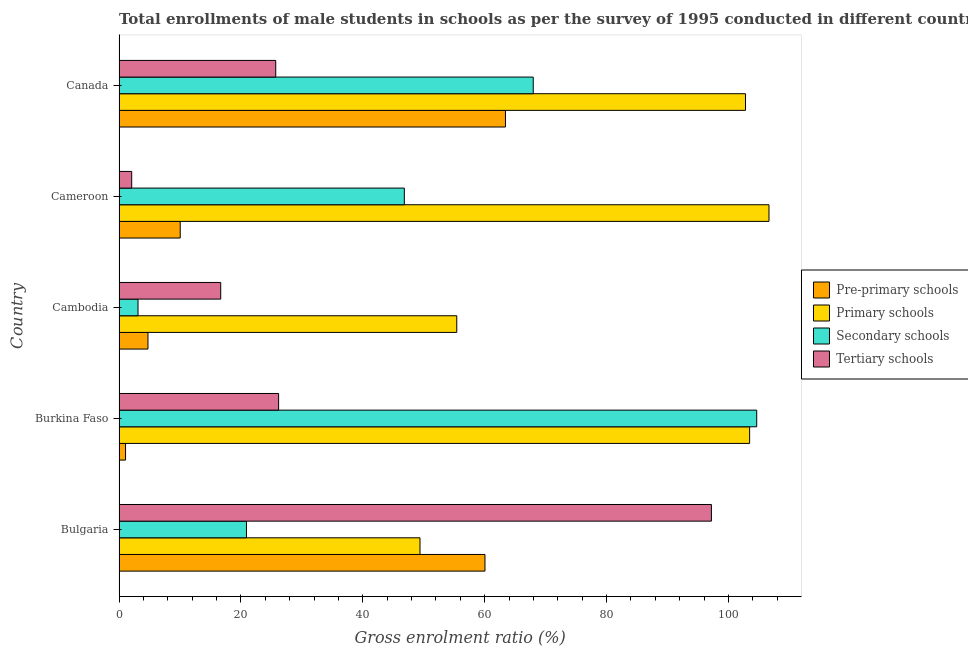How many bars are there on the 1st tick from the bottom?
Your answer should be compact. 4. What is the label of the 2nd group of bars from the top?
Keep it short and to the point. Cameroon. In how many cases, is the number of bars for a given country not equal to the number of legend labels?
Give a very brief answer. 0. What is the gross enrolment ratio(male) in secondary schools in Bulgaria?
Your answer should be very brief. 20.91. Across all countries, what is the maximum gross enrolment ratio(male) in primary schools?
Keep it short and to the point. 106.66. Across all countries, what is the minimum gross enrolment ratio(male) in secondary schools?
Provide a succinct answer. 3.11. In which country was the gross enrolment ratio(male) in tertiary schools maximum?
Provide a short and direct response. Bulgaria. What is the total gross enrolment ratio(male) in secondary schools in the graph?
Offer a terse response. 243.45. What is the difference between the gross enrolment ratio(male) in pre-primary schools in Burkina Faso and that in Cameroon?
Offer a terse response. -8.97. What is the difference between the gross enrolment ratio(male) in primary schools in Canada and the gross enrolment ratio(male) in pre-primary schools in Burkina Faso?
Offer a very short reply. 101.74. What is the average gross enrolment ratio(male) in primary schools per country?
Keep it short and to the point. 83.55. What is the difference between the gross enrolment ratio(male) in secondary schools and gross enrolment ratio(male) in primary schools in Canada?
Keep it short and to the point. -34.83. Is the gross enrolment ratio(male) in pre-primary schools in Cambodia less than that in Cameroon?
Give a very brief answer. Yes. What is the difference between the highest and the second highest gross enrolment ratio(male) in primary schools?
Your response must be concise. 3.18. What is the difference between the highest and the lowest gross enrolment ratio(male) in primary schools?
Provide a short and direct response. 57.27. What does the 3rd bar from the top in Burkina Faso represents?
Provide a succinct answer. Primary schools. What does the 1st bar from the bottom in Cameroon represents?
Keep it short and to the point. Pre-primary schools. Is it the case that in every country, the sum of the gross enrolment ratio(male) in pre-primary schools and gross enrolment ratio(male) in primary schools is greater than the gross enrolment ratio(male) in secondary schools?
Your answer should be compact. No. Are all the bars in the graph horizontal?
Give a very brief answer. Yes. How many countries are there in the graph?
Give a very brief answer. 5. What is the difference between two consecutive major ticks on the X-axis?
Provide a succinct answer. 20. Does the graph contain any zero values?
Ensure brevity in your answer.  No. Does the graph contain grids?
Keep it short and to the point. No. How many legend labels are there?
Provide a succinct answer. 4. What is the title of the graph?
Offer a very short reply. Total enrollments of male students in schools as per the survey of 1995 conducted in different countries. Does "Fish species" appear as one of the legend labels in the graph?
Offer a very short reply. No. What is the label or title of the Y-axis?
Make the answer very short. Country. What is the Gross enrolment ratio (%) of Pre-primary schools in Bulgaria?
Offer a very short reply. 60.05. What is the Gross enrolment ratio (%) in Primary schools in Bulgaria?
Provide a short and direct response. 49.39. What is the Gross enrolment ratio (%) of Secondary schools in Bulgaria?
Offer a terse response. 20.91. What is the Gross enrolment ratio (%) in Tertiary schools in Bulgaria?
Your response must be concise. 97.21. What is the Gross enrolment ratio (%) in Pre-primary schools in Burkina Faso?
Provide a succinct answer. 1.06. What is the Gross enrolment ratio (%) of Primary schools in Burkina Faso?
Offer a very short reply. 103.48. What is the Gross enrolment ratio (%) in Secondary schools in Burkina Faso?
Provide a succinct answer. 104.64. What is the Gross enrolment ratio (%) of Tertiary schools in Burkina Faso?
Your answer should be very brief. 26.18. What is the Gross enrolment ratio (%) of Pre-primary schools in Cambodia?
Offer a terse response. 4.75. What is the Gross enrolment ratio (%) in Primary schools in Cambodia?
Your answer should be compact. 55.42. What is the Gross enrolment ratio (%) in Secondary schools in Cambodia?
Your answer should be compact. 3.11. What is the Gross enrolment ratio (%) of Tertiary schools in Cambodia?
Provide a short and direct response. 16.68. What is the Gross enrolment ratio (%) of Pre-primary schools in Cameroon?
Your response must be concise. 10.04. What is the Gross enrolment ratio (%) of Primary schools in Cameroon?
Offer a very short reply. 106.66. What is the Gross enrolment ratio (%) of Secondary schools in Cameroon?
Offer a very short reply. 46.82. What is the Gross enrolment ratio (%) in Tertiary schools in Cameroon?
Provide a short and direct response. 2.08. What is the Gross enrolment ratio (%) of Pre-primary schools in Canada?
Give a very brief answer. 63.41. What is the Gross enrolment ratio (%) in Primary schools in Canada?
Ensure brevity in your answer.  102.8. What is the Gross enrolment ratio (%) in Secondary schools in Canada?
Ensure brevity in your answer.  67.97. What is the Gross enrolment ratio (%) of Tertiary schools in Canada?
Offer a very short reply. 25.71. Across all countries, what is the maximum Gross enrolment ratio (%) of Pre-primary schools?
Provide a succinct answer. 63.41. Across all countries, what is the maximum Gross enrolment ratio (%) of Primary schools?
Offer a very short reply. 106.66. Across all countries, what is the maximum Gross enrolment ratio (%) in Secondary schools?
Keep it short and to the point. 104.64. Across all countries, what is the maximum Gross enrolment ratio (%) of Tertiary schools?
Offer a terse response. 97.21. Across all countries, what is the minimum Gross enrolment ratio (%) in Pre-primary schools?
Provide a succinct answer. 1.06. Across all countries, what is the minimum Gross enrolment ratio (%) in Primary schools?
Keep it short and to the point. 49.39. Across all countries, what is the minimum Gross enrolment ratio (%) of Secondary schools?
Offer a very short reply. 3.11. Across all countries, what is the minimum Gross enrolment ratio (%) in Tertiary schools?
Your answer should be compact. 2.08. What is the total Gross enrolment ratio (%) in Pre-primary schools in the graph?
Ensure brevity in your answer.  139.31. What is the total Gross enrolment ratio (%) of Primary schools in the graph?
Make the answer very short. 417.76. What is the total Gross enrolment ratio (%) in Secondary schools in the graph?
Offer a terse response. 243.45. What is the total Gross enrolment ratio (%) of Tertiary schools in the graph?
Ensure brevity in your answer.  167.87. What is the difference between the Gross enrolment ratio (%) of Pre-primary schools in Bulgaria and that in Burkina Faso?
Keep it short and to the point. 58.99. What is the difference between the Gross enrolment ratio (%) in Primary schools in Bulgaria and that in Burkina Faso?
Your answer should be very brief. -54.09. What is the difference between the Gross enrolment ratio (%) in Secondary schools in Bulgaria and that in Burkina Faso?
Provide a succinct answer. -83.73. What is the difference between the Gross enrolment ratio (%) in Tertiary schools in Bulgaria and that in Burkina Faso?
Your response must be concise. 71.03. What is the difference between the Gross enrolment ratio (%) in Pre-primary schools in Bulgaria and that in Cambodia?
Make the answer very short. 55.3. What is the difference between the Gross enrolment ratio (%) in Primary schools in Bulgaria and that in Cambodia?
Offer a very short reply. -6.03. What is the difference between the Gross enrolment ratio (%) of Secondary schools in Bulgaria and that in Cambodia?
Provide a short and direct response. 17.8. What is the difference between the Gross enrolment ratio (%) of Tertiary schools in Bulgaria and that in Cambodia?
Keep it short and to the point. 80.53. What is the difference between the Gross enrolment ratio (%) of Pre-primary schools in Bulgaria and that in Cameroon?
Provide a short and direct response. 50.01. What is the difference between the Gross enrolment ratio (%) in Primary schools in Bulgaria and that in Cameroon?
Provide a succinct answer. -57.27. What is the difference between the Gross enrolment ratio (%) of Secondary schools in Bulgaria and that in Cameroon?
Ensure brevity in your answer.  -25.91. What is the difference between the Gross enrolment ratio (%) of Tertiary schools in Bulgaria and that in Cameroon?
Your answer should be very brief. 95.13. What is the difference between the Gross enrolment ratio (%) of Pre-primary schools in Bulgaria and that in Canada?
Provide a succinct answer. -3.36. What is the difference between the Gross enrolment ratio (%) in Primary schools in Bulgaria and that in Canada?
Ensure brevity in your answer.  -53.42. What is the difference between the Gross enrolment ratio (%) in Secondary schools in Bulgaria and that in Canada?
Offer a terse response. -47.06. What is the difference between the Gross enrolment ratio (%) in Tertiary schools in Bulgaria and that in Canada?
Ensure brevity in your answer.  71.5. What is the difference between the Gross enrolment ratio (%) of Pre-primary schools in Burkina Faso and that in Cambodia?
Your response must be concise. -3.68. What is the difference between the Gross enrolment ratio (%) of Primary schools in Burkina Faso and that in Cambodia?
Your response must be concise. 48.06. What is the difference between the Gross enrolment ratio (%) in Secondary schools in Burkina Faso and that in Cambodia?
Your response must be concise. 101.53. What is the difference between the Gross enrolment ratio (%) of Tertiary schools in Burkina Faso and that in Cambodia?
Your response must be concise. 9.5. What is the difference between the Gross enrolment ratio (%) of Pre-primary schools in Burkina Faso and that in Cameroon?
Make the answer very short. -8.97. What is the difference between the Gross enrolment ratio (%) of Primary schools in Burkina Faso and that in Cameroon?
Ensure brevity in your answer.  -3.18. What is the difference between the Gross enrolment ratio (%) in Secondary schools in Burkina Faso and that in Cameroon?
Your response must be concise. 57.83. What is the difference between the Gross enrolment ratio (%) of Tertiary schools in Burkina Faso and that in Cameroon?
Your answer should be very brief. 24.11. What is the difference between the Gross enrolment ratio (%) in Pre-primary schools in Burkina Faso and that in Canada?
Offer a very short reply. -62.35. What is the difference between the Gross enrolment ratio (%) in Primary schools in Burkina Faso and that in Canada?
Give a very brief answer. 0.68. What is the difference between the Gross enrolment ratio (%) of Secondary schools in Burkina Faso and that in Canada?
Provide a succinct answer. 36.67. What is the difference between the Gross enrolment ratio (%) in Tertiary schools in Burkina Faso and that in Canada?
Keep it short and to the point. 0.47. What is the difference between the Gross enrolment ratio (%) in Pre-primary schools in Cambodia and that in Cameroon?
Make the answer very short. -5.29. What is the difference between the Gross enrolment ratio (%) in Primary schools in Cambodia and that in Cameroon?
Give a very brief answer. -51.24. What is the difference between the Gross enrolment ratio (%) of Secondary schools in Cambodia and that in Cameroon?
Your response must be concise. -43.71. What is the difference between the Gross enrolment ratio (%) of Tertiary schools in Cambodia and that in Cameroon?
Ensure brevity in your answer.  14.61. What is the difference between the Gross enrolment ratio (%) of Pre-primary schools in Cambodia and that in Canada?
Offer a terse response. -58.67. What is the difference between the Gross enrolment ratio (%) of Primary schools in Cambodia and that in Canada?
Keep it short and to the point. -47.38. What is the difference between the Gross enrolment ratio (%) in Secondary schools in Cambodia and that in Canada?
Your answer should be very brief. -64.86. What is the difference between the Gross enrolment ratio (%) of Tertiary schools in Cambodia and that in Canada?
Your answer should be very brief. -9.03. What is the difference between the Gross enrolment ratio (%) of Pre-primary schools in Cameroon and that in Canada?
Your response must be concise. -53.38. What is the difference between the Gross enrolment ratio (%) of Primary schools in Cameroon and that in Canada?
Your answer should be very brief. 3.85. What is the difference between the Gross enrolment ratio (%) of Secondary schools in Cameroon and that in Canada?
Ensure brevity in your answer.  -21.15. What is the difference between the Gross enrolment ratio (%) of Tertiary schools in Cameroon and that in Canada?
Make the answer very short. -23.64. What is the difference between the Gross enrolment ratio (%) of Pre-primary schools in Bulgaria and the Gross enrolment ratio (%) of Primary schools in Burkina Faso?
Provide a succinct answer. -43.43. What is the difference between the Gross enrolment ratio (%) in Pre-primary schools in Bulgaria and the Gross enrolment ratio (%) in Secondary schools in Burkina Faso?
Ensure brevity in your answer.  -44.59. What is the difference between the Gross enrolment ratio (%) of Pre-primary schools in Bulgaria and the Gross enrolment ratio (%) of Tertiary schools in Burkina Faso?
Give a very brief answer. 33.87. What is the difference between the Gross enrolment ratio (%) in Primary schools in Bulgaria and the Gross enrolment ratio (%) in Secondary schools in Burkina Faso?
Your response must be concise. -55.26. What is the difference between the Gross enrolment ratio (%) of Primary schools in Bulgaria and the Gross enrolment ratio (%) of Tertiary schools in Burkina Faso?
Make the answer very short. 23.2. What is the difference between the Gross enrolment ratio (%) of Secondary schools in Bulgaria and the Gross enrolment ratio (%) of Tertiary schools in Burkina Faso?
Provide a succinct answer. -5.27. What is the difference between the Gross enrolment ratio (%) of Pre-primary schools in Bulgaria and the Gross enrolment ratio (%) of Primary schools in Cambodia?
Offer a very short reply. 4.63. What is the difference between the Gross enrolment ratio (%) in Pre-primary schools in Bulgaria and the Gross enrolment ratio (%) in Secondary schools in Cambodia?
Ensure brevity in your answer.  56.94. What is the difference between the Gross enrolment ratio (%) of Pre-primary schools in Bulgaria and the Gross enrolment ratio (%) of Tertiary schools in Cambodia?
Your answer should be very brief. 43.37. What is the difference between the Gross enrolment ratio (%) of Primary schools in Bulgaria and the Gross enrolment ratio (%) of Secondary schools in Cambodia?
Keep it short and to the point. 46.28. What is the difference between the Gross enrolment ratio (%) of Primary schools in Bulgaria and the Gross enrolment ratio (%) of Tertiary schools in Cambodia?
Your response must be concise. 32.7. What is the difference between the Gross enrolment ratio (%) in Secondary schools in Bulgaria and the Gross enrolment ratio (%) in Tertiary schools in Cambodia?
Your answer should be compact. 4.23. What is the difference between the Gross enrolment ratio (%) in Pre-primary schools in Bulgaria and the Gross enrolment ratio (%) in Primary schools in Cameroon?
Offer a very short reply. -46.61. What is the difference between the Gross enrolment ratio (%) of Pre-primary schools in Bulgaria and the Gross enrolment ratio (%) of Secondary schools in Cameroon?
Make the answer very short. 13.23. What is the difference between the Gross enrolment ratio (%) in Pre-primary schools in Bulgaria and the Gross enrolment ratio (%) in Tertiary schools in Cameroon?
Provide a succinct answer. 57.98. What is the difference between the Gross enrolment ratio (%) of Primary schools in Bulgaria and the Gross enrolment ratio (%) of Secondary schools in Cameroon?
Your response must be concise. 2.57. What is the difference between the Gross enrolment ratio (%) in Primary schools in Bulgaria and the Gross enrolment ratio (%) in Tertiary schools in Cameroon?
Make the answer very short. 47.31. What is the difference between the Gross enrolment ratio (%) in Secondary schools in Bulgaria and the Gross enrolment ratio (%) in Tertiary schools in Cameroon?
Your response must be concise. 18.83. What is the difference between the Gross enrolment ratio (%) in Pre-primary schools in Bulgaria and the Gross enrolment ratio (%) in Primary schools in Canada?
Your answer should be very brief. -42.75. What is the difference between the Gross enrolment ratio (%) in Pre-primary schools in Bulgaria and the Gross enrolment ratio (%) in Secondary schools in Canada?
Give a very brief answer. -7.92. What is the difference between the Gross enrolment ratio (%) in Pre-primary schools in Bulgaria and the Gross enrolment ratio (%) in Tertiary schools in Canada?
Keep it short and to the point. 34.34. What is the difference between the Gross enrolment ratio (%) in Primary schools in Bulgaria and the Gross enrolment ratio (%) in Secondary schools in Canada?
Give a very brief answer. -18.58. What is the difference between the Gross enrolment ratio (%) in Primary schools in Bulgaria and the Gross enrolment ratio (%) in Tertiary schools in Canada?
Keep it short and to the point. 23.68. What is the difference between the Gross enrolment ratio (%) of Secondary schools in Bulgaria and the Gross enrolment ratio (%) of Tertiary schools in Canada?
Offer a very short reply. -4.8. What is the difference between the Gross enrolment ratio (%) in Pre-primary schools in Burkina Faso and the Gross enrolment ratio (%) in Primary schools in Cambodia?
Provide a short and direct response. -54.36. What is the difference between the Gross enrolment ratio (%) of Pre-primary schools in Burkina Faso and the Gross enrolment ratio (%) of Secondary schools in Cambodia?
Your answer should be very brief. -2.05. What is the difference between the Gross enrolment ratio (%) of Pre-primary schools in Burkina Faso and the Gross enrolment ratio (%) of Tertiary schools in Cambodia?
Offer a very short reply. -15.62. What is the difference between the Gross enrolment ratio (%) of Primary schools in Burkina Faso and the Gross enrolment ratio (%) of Secondary schools in Cambodia?
Your response must be concise. 100.37. What is the difference between the Gross enrolment ratio (%) in Primary schools in Burkina Faso and the Gross enrolment ratio (%) in Tertiary schools in Cambodia?
Give a very brief answer. 86.8. What is the difference between the Gross enrolment ratio (%) in Secondary schools in Burkina Faso and the Gross enrolment ratio (%) in Tertiary schools in Cambodia?
Your answer should be very brief. 87.96. What is the difference between the Gross enrolment ratio (%) of Pre-primary schools in Burkina Faso and the Gross enrolment ratio (%) of Primary schools in Cameroon?
Give a very brief answer. -105.59. What is the difference between the Gross enrolment ratio (%) in Pre-primary schools in Burkina Faso and the Gross enrolment ratio (%) in Secondary schools in Cameroon?
Provide a short and direct response. -45.75. What is the difference between the Gross enrolment ratio (%) in Pre-primary schools in Burkina Faso and the Gross enrolment ratio (%) in Tertiary schools in Cameroon?
Your response must be concise. -1.01. What is the difference between the Gross enrolment ratio (%) in Primary schools in Burkina Faso and the Gross enrolment ratio (%) in Secondary schools in Cameroon?
Offer a very short reply. 56.67. What is the difference between the Gross enrolment ratio (%) in Primary schools in Burkina Faso and the Gross enrolment ratio (%) in Tertiary schools in Cameroon?
Give a very brief answer. 101.41. What is the difference between the Gross enrolment ratio (%) of Secondary schools in Burkina Faso and the Gross enrolment ratio (%) of Tertiary schools in Cameroon?
Your answer should be compact. 102.57. What is the difference between the Gross enrolment ratio (%) in Pre-primary schools in Burkina Faso and the Gross enrolment ratio (%) in Primary schools in Canada?
Offer a terse response. -101.74. What is the difference between the Gross enrolment ratio (%) of Pre-primary schools in Burkina Faso and the Gross enrolment ratio (%) of Secondary schools in Canada?
Offer a terse response. -66.91. What is the difference between the Gross enrolment ratio (%) in Pre-primary schools in Burkina Faso and the Gross enrolment ratio (%) in Tertiary schools in Canada?
Offer a terse response. -24.65. What is the difference between the Gross enrolment ratio (%) of Primary schools in Burkina Faso and the Gross enrolment ratio (%) of Secondary schools in Canada?
Make the answer very short. 35.51. What is the difference between the Gross enrolment ratio (%) of Primary schools in Burkina Faso and the Gross enrolment ratio (%) of Tertiary schools in Canada?
Provide a short and direct response. 77.77. What is the difference between the Gross enrolment ratio (%) of Secondary schools in Burkina Faso and the Gross enrolment ratio (%) of Tertiary schools in Canada?
Give a very brief answer. 78.93. What is the difference between the Gross enrolment ratio (%) of Pre-primary schools in Cambodia and the Gross enrolment ratio (%) of Primary schools in Cameroon?
Give a very brief answer. -101.91. What is the difference between the Gross enrolment ratio (%) of Pre-primary schools in Cambodia and the Gross enrolment ratio (%) of Secondary schools in Cameroon?
Provide a succinct answer. -42.07. What is the difference between the Gross enrolment ratio (%) of Pre-primary schools in Cambodia and the Gross enrolment ratio (%) of Tertiary schools in Cameroon?
Keep it short and to the point. 2.67. What is the difference between the Gross enrolment ratio (%) of Primary schools in Cambodia and the Gross enrolment ratio (%) of Secondary schools in Cameroon?
Make the answer very short. 8.6. What is the difference between the Gross enrolment ratio (%) in Primary schools in Cambodia and the Gross enrolment ratio (%) in Tertiary schools in Cameroon?
Your answer should be very brief. 53.35. What is the difference between the Gross enrolment ratio (%) of Secondary schools in Cambodia and the Gross enrolment ratio (%) of Tertiary schools in Cameroon?
Provide a short and direct response. 1.04. What is the difference between the Gross enrolment ratio (%) of Pre-primary schools in Cambodia and the Gross enrolment ratio (%) of Primary schools in Canada?
Your response must be concise. -98.06. What is the difference between the Gross enrolment ratio (%) in Pre-primary schools in Cambodia and the Gross enrolment ratio (%) in Secondary schools in Canada?
Offer a very short reply. -63.22. What is the difference between the Gross enrolment ratio (%) of Pre-primary schools in Cambodia and the Gross enrolment ratio (%) of Tertiary schools in Canada?
Provide a succinct answer. -20.97. What is the difference between the Gross enrolment ratio (%) in Primary schools in Cambodia and the Gross enrolment ratio (%) in Secondary schools in Canada?
Your answer should be very brief. -12.55. What is the difference between the Gross enrolment ratio (%) in Primary schools in Cambodia and the Gross enrolment ratio (%) in Tertiary schools in Canada?
Your response must be concise. 29.71. What is the difference between the Gross enrolment ratio (%) in Secondary schools in Cambodia and the Gross enrolment ratio (%) in Tertiary schools in Canada?
Make the answer very short. -22.6. What is the difference between the Gross enrolment ratio (%) in Pre-primary schools in Cameroon and the Gross enrolment ratio (%) in Primary schools in Canada?
Give a very brief answer. -92.77. What is the difference between the Gross enrolment ratio (%) of Pre-primary schools in Cameroon and the Gross enrolment ratio (%) of Secondary schools in Canada?
Provide a succinct answer. -57.93. What is the difference between the Gross enrolment ratio (%) of Pre-primary schools in Cameroon and the Gross enrolment ratio (%) of Tertiary schools in Canada?
Give a very brief answer. -15.68. What is the difference between the Gross enrolment ratio (%) in Primary schools in Cameroon and the Gross enrolment ratio (%) in Secondary schools in Canada?
Provide a short and direct response. 38.69. What is the difference between the Gross enrolment ratio (%) of Primary schools in Cameroon and the Gross enrolment ratio (%) of Tertiary schools in Canada?
Your answer should be very brief. 80.95. What is the difference between the Gross enrolment ratio (%) of Secondary schools in Cameroon and the Gross enrolment ratio (%) of Tertiary schools in Canada?
Provide a short and direct response. 21.1. What is the average Gross enrolment ratio (%) in Pre-primary schools per country?
Make the answer very short. 27.86. What is the average Gross enrolment ratio (%) of Primary schools per country?
Ensure brevity in your answer.  83.55. What is the average Gross enrolment ratio (%) of Secondary schools per country?
Provide a short and direct response. 48.69. What is the average Gross enrolment ratio (%) in Tertiary schools per country?
Your response must be concise. 33.57. What is the difference between the Gross enrolment ratio (%) of Pre-primary schools and Gross enrolment ratio (%) of Primary schools in Bulgaria?
Keep it short and to the point. 10.66. What is the difference between the Gross enrolment ratio (%) in Pre-primary schools and Gross enrolment ratio (%) in Secondary schools in Bulgaria?
Provide a short and direct response. 39.14. What is the difference between the Gross enrolment ratio (%) of Pre-primary schools and Gross enrolment ratio (%) of Tertiary schools in Bulgaria?
Your answer should be very brief. -37.16. What is the difference between the Gross enrolment ratio (%) of Primary schools and Gross enrolment ratio (%) of Secondary schools in Bulgaria?
Keep it short and to the point. 28.48. What is the difference between the Gross enrolment ratio (%) in Primary schools and Gross enrolment ratio (%) in Tertiary schools in Bulgaria?
Keep it short and to the point. -47.82. What is the difference between the Gross enrolment ratio (%) in Secondary schools and Gross enrolment ratio (%) in Tertiary schools in Bulgaria?
Offer a terse response. -76.3. What is the difference between the Gross enrolment ratio (%) in Pre-primary schools and Gross enrolment ratio (%) in Primary schools in Burkina Faso?
Offer a very short reply. -102.42. What is the difference between the Gross enrolment ratio (%) of Pre-primary schools and Gross enrolment ratio (%) of Secondary schools in Burkina Faso?
Your response must be concise. -103.58. What is the difference between the Gross enrolment ratio (%) of Pre-primary schools and Gross enrolment ratio (%) of Tertiary schools in Burkina Faso?
Offer a very short reply. -25.12. What is the difference between the Gross enrolment ratio (%) of Primary schools and Gross enrolment ratio (%) of Secondary schools in Burkina Faso?
Offer a terse response. -1.16. What is the difference between the Gross enrolment ratio (%) in Primary schools and Gross enrolment ratio (%) in Tertiary schools in Burkina Faso?
Make the answer very short. 77.3. What is the difference between the Gross enrolment ratio (%) in Secondary schools and Gross enrolment ratio (%) in Tertiary schools in Burkina Faso?
Your answer should be compact. 78.46. What is the difference between the Gross enrolment ratio (%) in Pre-primary schools and Gross enrolment ratio (%) in Primary schools in Cambodia?
Provide a succinct answer. -50.68. What is the difference between the Gross enrolment ratio (%) of Pre-primary schools and Gross enrolment ratio (%) of Secondary schools in Cambodia?
Make the answer very short. 1.63. What is the difference between the Gross enrolment ratio (%) in Pre-primary schools and Gross enrolment ratio (%) in Tertiary schools in Cambodia?
Your response must be concise. -11.94. What is the difference between the Gross enrolment ratio (%) of Primary schools and Gross enrolment ratio (%) of Secondary schools in Cambodia?
Offer a terse response. 52.31. What is the difference between the Gross enrolment ratio (%) of Primary schools and Gross enrolment ratio (%) of Tertiary schools in Cambodia?
Provide a short and direct response. 38.74. What is the difference between the Gross enrolment ratio (%) in Secondary schools and Gross enrolment ratio (%) in Tertiary schools in Cambodia?
Ensure brevity in your answer.  -13.57. What is the difference between the Gross enrolment ratio (%) in Pre-primary schools and Gross enrolment ratio (%) in Primary schools in Cameroon?
Give a very brief answer. -96.62. What is the difference between the Gross enrolment ratio (%) of Pre-primary schools and Gross enrolment ratio (%) of Secondary schools in Cameroon?
Ensure brevity in your answer.  -36.78. What is the difference between the Gross enrolment ratio (%) in Pre-primary schools and Gross enrolment ratio (%) in Tertiary schools in Cameroon?
Keep it short and to the point. 7.96. What is the difference between the Gross enrolment ratio (%) in Primary schools and Gross enrolment ratio (%) in Secondary schools in Cameroon?
Provide a short and direct response. 59.84. What is the difference between the Gross enrolment ratio (%) of Primary schools and Gross enrolment ratio (%) of Tertiary schools in Cameroon?
Offer a terse response. 104.58. What is the difference between the Gross enrolment ratio (%) of Secondary schools and Gross enrolment ratio (%) of Tertiary schools in Cameroon?
Offer a very short reply. 44.74. What is the difference between the Gross enrolment ratio (%) in Pre-primary schools and Gross enrolment ratio (%) in Primary schools in Canada?
Your response must be concise. -39.39. What is the difference between the Gross enrolment ratio (%) of Pre-primary schools and Gross enrolment ratio (%) of Secondary schools in Canada?
Offer a very short reply. -4.56. What is the difference between the Gross enrolment ratio (%) in Pre-primary schools and Gross enrolment ratio (%) in Tertiary schools in Canada?
Provide a short and direct response. 37.7. What is the difference between the Gross enrolment ratio (%) in Primary schools and Gross enrolment ratio (%) in Secondary schools in Canada?
Offer a terse response. 34.83. What is the difference between the Gross enrolment ratio (%) in Primary schools and Gross enrolment ratio (%) in Tertiary schools in Canada?
Provide a short and direct response. 77.09. What is the difference between the Gross enrolment ratio (%) in Secondary schools and Gross enrolment ratio (%) in Tertiary schools in Canada?
Ensure brevity in your answer.  42.26. What is the ratio of the Gross enrolment ratio (%) of Pre-primary schools in Bulgaria to that in Burkina Faso?
Ensure brevity in your answer.  56.41. What is the ratio of the Gross enrolment ratio (%) in Primary schools in Bulgaria to that in Burkina Faso?
Your answer should be compact. 0.48. What is the ratio of the Gross enrolment ratio (%) in Secondary schools in Bulgaria to that in Burkina Faso?
Provide a succinct answer. 0.2. What is the ratio of the Gross enrolment ratio (%) of Tertiary schools in Bulgaria to that in Burkina Faso?
Offer a terse response. 3.71. What is the ratio of the Gross enrolment ratio (%) of Pre-primary schools in Bulgaria to that in Cambodia?
Ensure brevity in your answer.  12.65. What is the ratio of the Gross enrolment ratio (%) in Primary schools in Bulgaria to that in Cambodia?
Provide a short and direct response. 0.89. What is the ratio of the Gross enrolment ratio (%) of Secondary schools in Bulgaria to that in Cambodia?
Offer a very short reply. 6.72. What is the ratio of the Gross enrolment ratio (%) of Tertiary schools in Bulgaria to that in Cambodia?
Ensure brevity in your answer.  5.83. What is the ratio of the Gross enrolment ratio (%) in Pre-primary schools in Bulgaria to that in Cameroon?
Provide a short and direct response. 5.98. What is the ratio of the Gross enrolment ratio (%) in Primary schools in Bulgaria to that in Cameroon?
Offer a very short reply. 0.46. What is the ratio of the Gross enrolment ratio (%) of Secondary schools in Bulgaria to that in Cameroon?
Ensure brevity in your answer.  0.45. What is the ratio of the Gross enrolment ratio (%) in Tertiary schools in Bulgaria to that in Cameroon?
Offer a very short reply. 46.83. What is the ratio of the Gross enrolment ratio (%) in Pre-primary schools in Bulgaria to that in Canada?
Offer a very short reply. 0.95. What is the ratio of the Gross enrolment ratio (%) in Primary schools in Bulgaria to that in Canada?
Provide a succinct answer. 0.48. What is the ratio of the Gross enrolment ratio (%) of Secondary schools in Bulgaria to that in Canada?
Ensure brevity in your answer.  0.31. What is the ratio of the Gross enrolment ratio (%) in Tertiary schools in Bulgaria to that in Canada?
Keep it short and to the point. 3.78. What is the ratio of the Gross enrolment ratio (%) in Pre-primary schools in Burkina Faso to that in Cambodia?
Keep it short and to the point. 0.22. What is the ratio of the Gross enrolment ratio (%) of Primary schools in Burkina Faso to that in Cambodia?
Your answer should be compact. 1.87. What is the ratio of the Gross enrolment ratio (%) in Secondary schools in Burkina Faso to that in Cambodia?
Make the answer very short. 33.63. What is the ratio of the Gross enrolment ratio (%) in Tertiary schools in Burkina Faso to that in Cambodia?
Your answer should be compact. 1.57. What is the ratio of the Gross enrolment ratio (%) of Pre-primary schools in Burkina Faso to that in Cameroon?
Offer a terse response. 0.11. What is the ratio of the Gross enrolment ratio (%) of Primary schools in Burkina Faso to that in Cameroon?
Provide a succinct answer. 0.97. What is the ratio of the Gross enrolment ratio (%) of Secondary schools in Burkina Faso to that in Cameroon?
Offer a terse response. 2.24. What is the ratio of the Gross enrolment ratio (%) in Tertiary schools in Burkina Faso to that in Cameroon?
Offer a very short reply. 12.61. What is the ratio of the Gross enrolment ratio (%) in Pre-primary schools in Burkina Faso to that in Canada?
Offer a terse response. 0.02. What is the ratio of the Gross enrolment ratio (%) in Primary schools in Burkina Faso to that in Canada?
Give a very brief answer. 1.01. What is the ratio of the Gross enrolment ratio (%) of Secondary schools in Burkina Faso to that in Canada?
Your answer should be compact. 1.54. What is the ratio of the Gross enrolment ratio (%) in Tertiary schools in Burkina Faso to that in Canada?
Offer a terse response. 1.02. What is the ratio of the Gross enrolment ratio (%) in Pre-primary schools in Cambodia to that in Cameroon?
Offer a very short reply. 0.47. What is the ratio of the Gross enrolment ratio (%) of Primary schools in Cambodia to that in Cameroon?
Provide a short and direct response. 0.52. What is the ratio of the Gross enrolment ratio (%) in Secondary schools in Cambodia to that in Cameroon?
Offer a terse response. 0.07. What is the ratio of the Gross enrolment ratio (%) of Tertiary schools in Cambodia to that in Cameroon?
Ensure brevity in your answer.  8.04. What is the ratio of the Gross enrolment ratio (%) of Pre-primary schools in Cambodia to that in Canada?
Provide a succinct answer. 0.07. What is the ratio of the Gross enrolment ratio (%) of Primary schools in Cambodia to that in Canada?
Offer a very short reply. 0.54. What is the ratio of the Gross enrolment ratio (%) in Secondary schools in Cambodia to that in Canada?
Your response must be concise. 0.05. What is the ratio of the Gross enrolment ratio (%) in Tertiary schools in Cambodia to that in Canada?
Make the answer very short. 0.65. What is the ratio of the Gross enrolment ratio (%) in Pre-primary schools in Cameroon to that in Canada?
Provide a short and direct response. 0.16. What is the ratio of the Gross enrolment ratio (%) in Primary schools in Cameroon to that in Canada?
Make the answer very short. 1.04. What is the ratio of the Gross enrolment ratio (%) in Secondary schools in Cameroon to that in Canada?
Your response must be concise. 0.69. What is the ratio of the Gross enrolment ratio (%) of Tertiary schools in Cameroon to that in Canada?
Your answer should be very brief. 0.08. What is the difference between the highest and the second highest Gross enrolment ratio (%) of Pre-primary schools?
Offer a very short reply. 3.36. What is the difference between the highest and the second highest Gross enrolment ratio (%) in Primary schools?
Offer a terse response. 3.18. What is the difference between the highest and the second highest Gross enrolment ratio (%) of Secondary schools?
Your answer should be compact. 36.67. What is the difference between the highest and the second highest Gross enrolment ratio (%) of Tertiary schools?
Provide a short and direct response. 71.03. What is the difference between the highest and the lowest Gross enrolment ratio (%) of Pre-primary schools?
Provide a succinct answer. 62.35. What is the difference between the highest and the lowest Gross enrolment ratio (%) of Primary schools?
Give a very brief answer. 57.27. What is the difference between the highest and the lowest Gross enrolment ratio (%) in Secondary schools?
Provide a short and direct response. 101.53. What is the difference between the highest and the lowest Gross enrolment ratio (%) of Tertiary schools?
Offer a terse response. 95.13. 